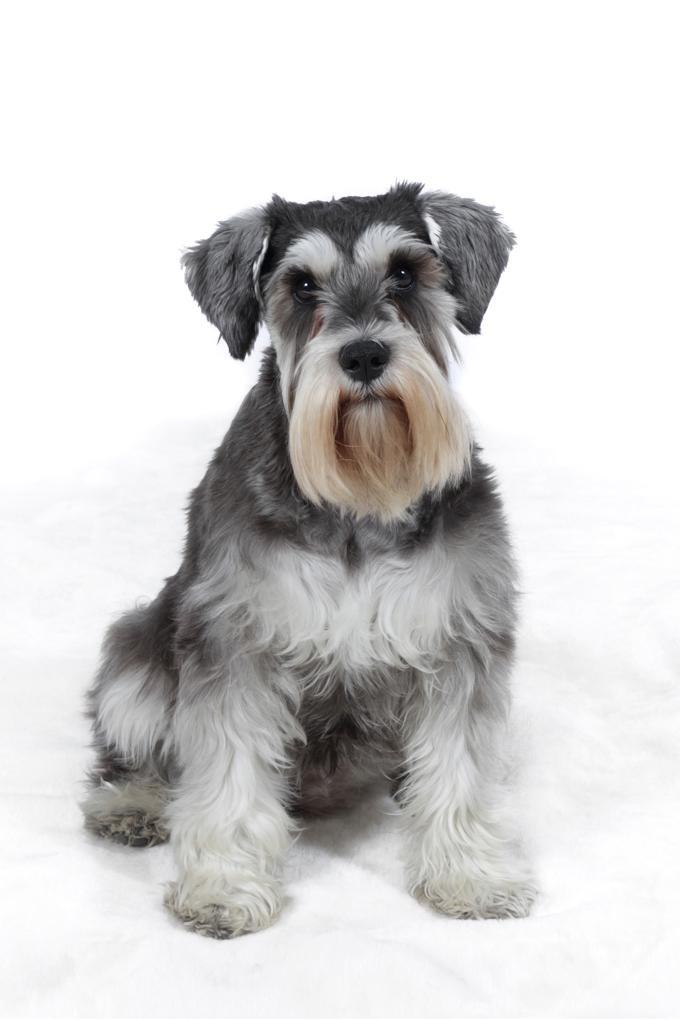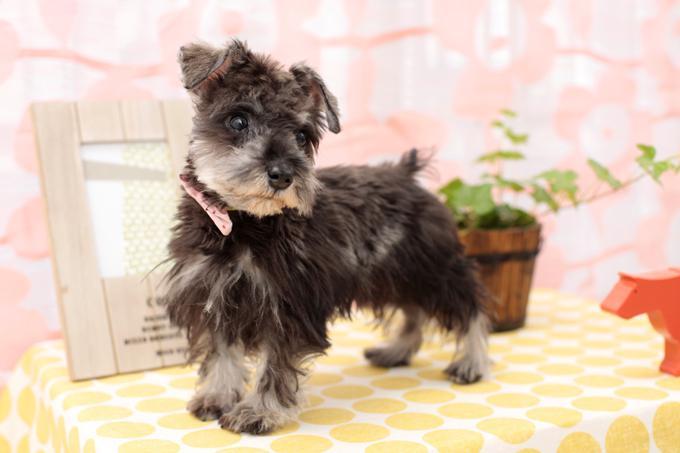The first image is the image on the left, the second image is the image on the right. For the images displayed, is the sentence "At least one of the dogs has its mouth open." factually correct? Answer yes or no. No. 